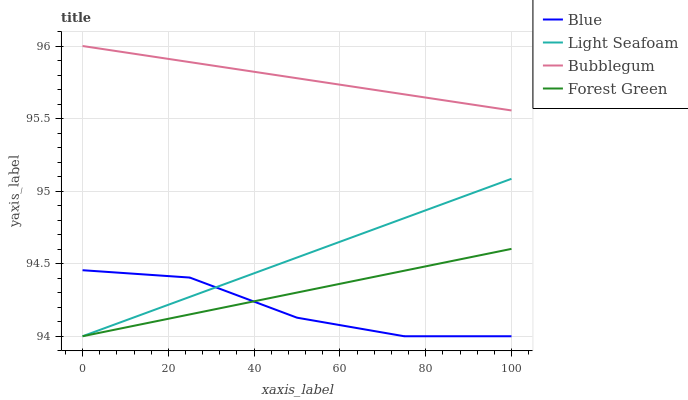Does Blue have the minimum area under the curve?
Answer yes or no. Yes. Does Bubblegum have the maximum area under the curve?
Answer yes or no. Yes. Does Forest Green have the minimum area under the curve?
Answer yes or no. No. Does Forest Green have the maximum area under the curve?
Answer yes or no. No. Is Forest Green the smoothest?
Answer yes or no. Yes. Is Blue the roughest?
Answer yes or no. Yes. Is Light Seafoam the smoothest?
Answer yes or no. No. Is Light Seafoam the roughest?
Answer yes or no. No. Does Blue have the lowest value?
Answer yes or no. Yes. Does Bubblegum have the lowest value?
Answer yes or no. No. Does Bubblegum have the highest value?
Answer yes or no. Yes. Does Forest Green have the highest value?
Answer yes or no. No. Is Blue less than Bubblegum?
Answer yes or no. Yes. Is Bubblegum greater than Blue?
Answer yes or no. Yes. Does Blue intersect Forest Green?
Answer yes or no. Yes. Is Blue less than Forest Green?
Answer yes or no. No. Is Blue greater than Forest Green?
Answer yes or no. No. Does Blue intersect Bubblegum?
Answer yes or no. No. 